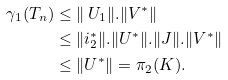<formula> <loc_0><loc_0><loc_500><loc_500>\gamma _ { 1 } ( T _ { n } ) & \leq \| \ U _ { 1 } \| . \| V ^ { * } \| \\ & \leq \| i ^ { * } _ { 2 } \| . \| U ^ { * } \| . \| J \| . \| V ^ { * } \| \\ & \leq \| U ^ { * } \| = \pi _ { 2 } ( K ) .</formula> 